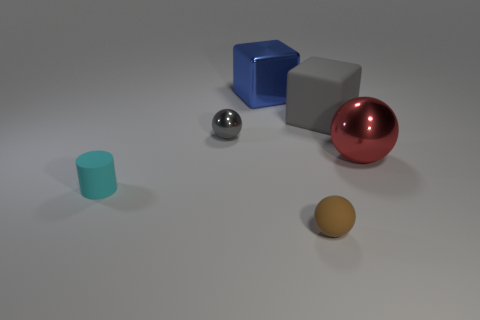How many other things are there of the same material as the large red thing?
Your answer should be compact. 2. What is the color of the metal sphere that is behind the red shiny ball to the right of the small gray shiny ball?
Keep it short and to the point. Gray. There is a big cube that is right of the tiny matte ball; does it have the same color as the small shiny object?
Provide a short and direct response. Yes. Do the cyan matte cylinder and the gray shiny object have the same size?
Offer a terse response. Yes. The gray matte object that is the same size as the red shiny ball is what shape?
Keep it short and to the point. Cube. Does the shiny sphere that is on the left side of the brown sphere have the same size as the small cyan object?
Provide a succinct answer. Yes. What is the material of the gray object that is the same size as the blue metal block?
Keep it short and to the point. Rubber. Are there any metallic things behind the big metal object that is in front of the thing behind the large gray rubber cube?
Give a very brief answer. Yes. Are there any other things that are the same shape as the small cyan thing?
Offer a very short reply. No. There is a rubber thing that is on the right side of the brown matte object; does it have the same color as the small ball behind the small matte cylinder?
Make the answer very short. Yes. 